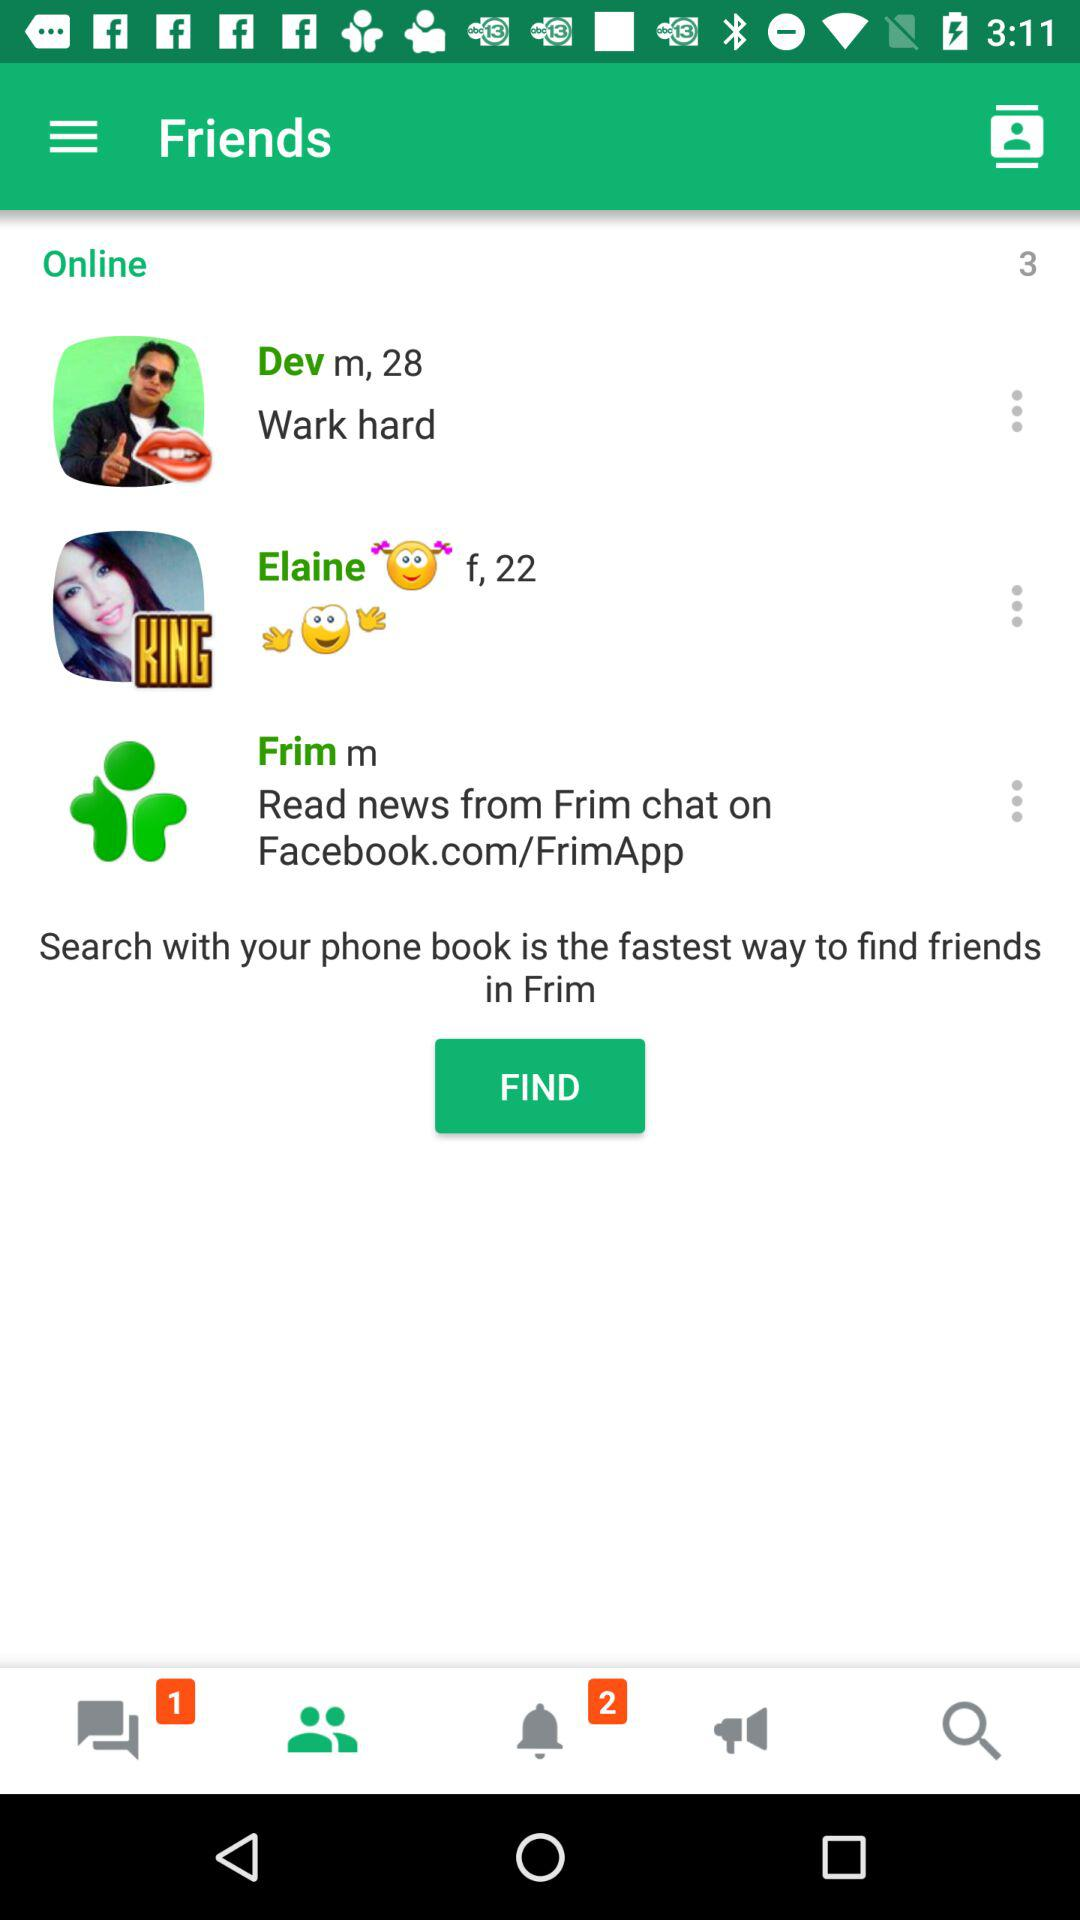How old is Elaine? Elaine is 22 years old. 